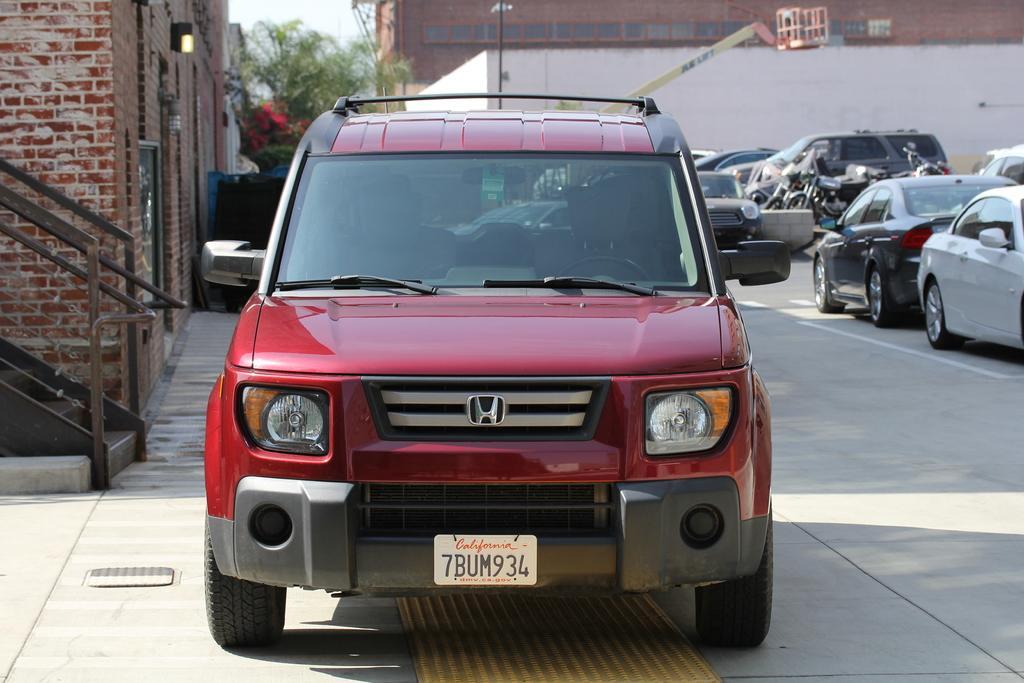Please provide a concise description of this image. On the left side of the image we can see the steps and the wall. In the middle of the image we can see a red color car, trees and building. On the right side of the image we can see cars and bikes. 